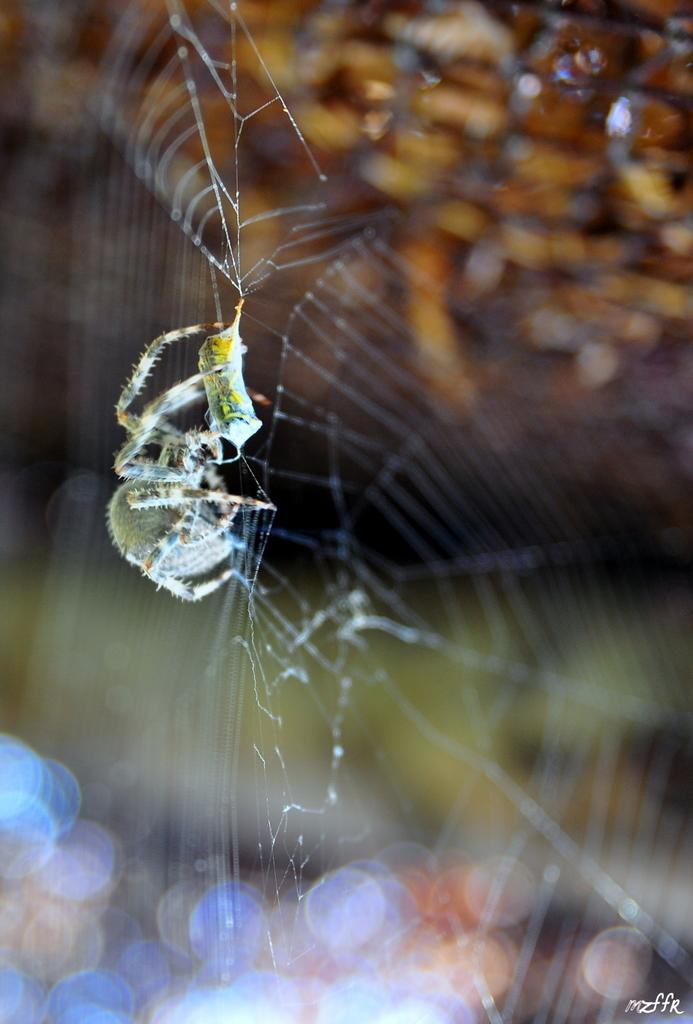What is the main subject of the image? There is a spider in the image. Where is the spider located? The spider is on a spider web. Can you describe the background of the image? The background of the image is blurry. What type of shoes is the spider's partner wearing in the image? There is no partner or shoes present in the image, as it features a spider on a spider web with a blurry background. 